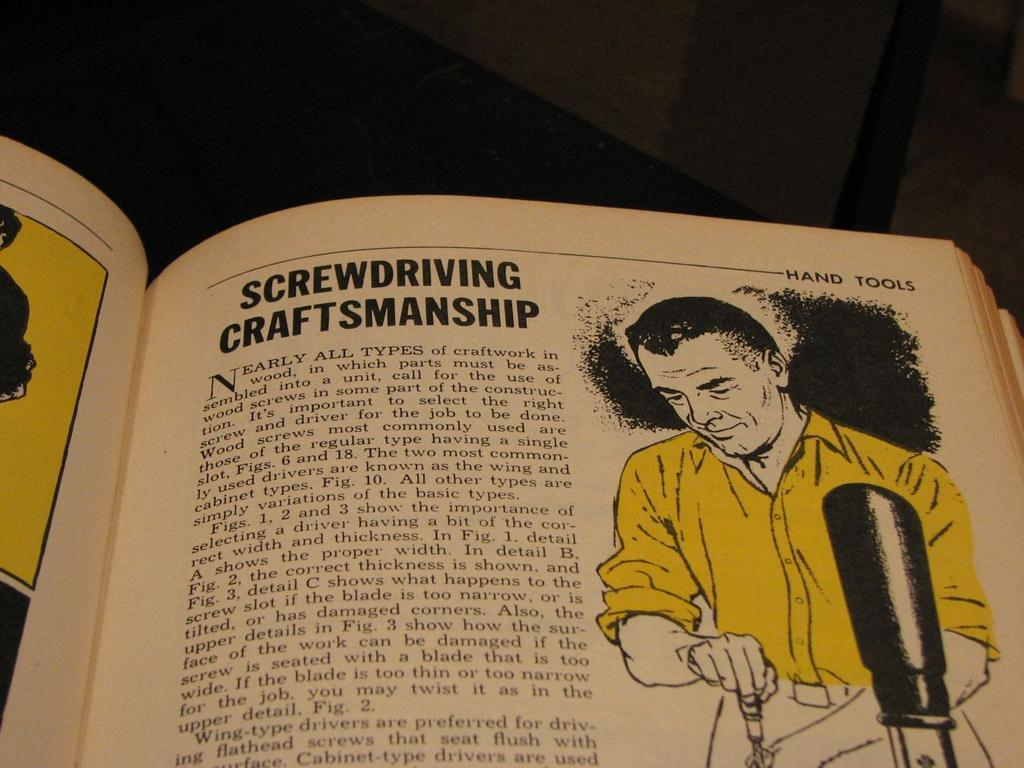<image>
Relay a brief, clear account of the picture shown. An old book on hand tools opened to a page on screwdriver craftsmanship. 